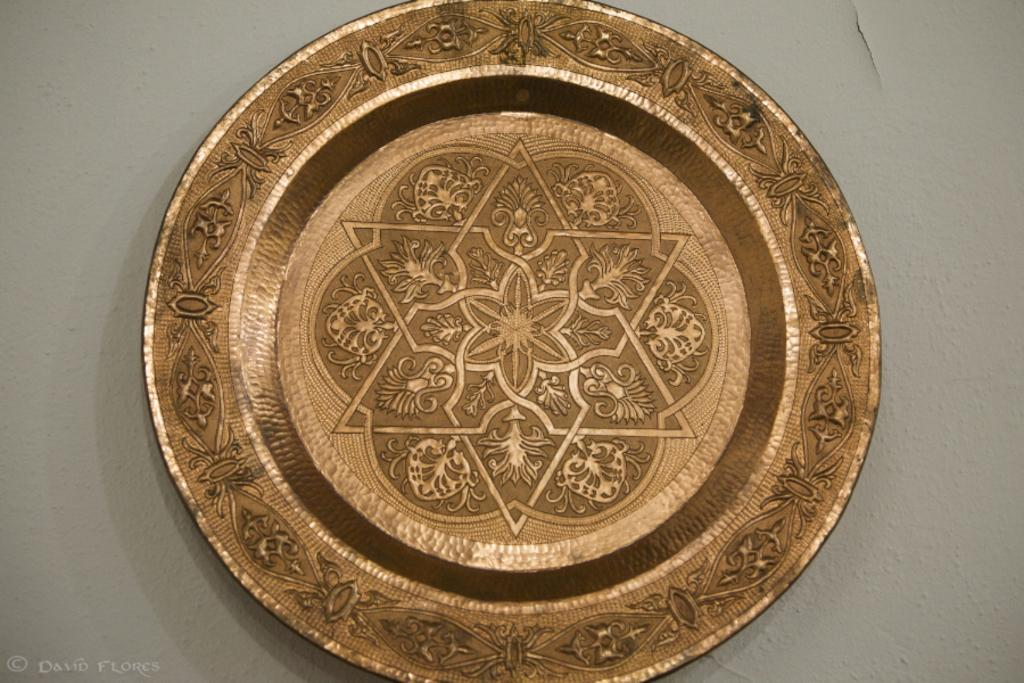What material is the plate made of in the image? The plate is made of bronze in the image. What can be seen on the surface of the plate? The plate has a design on it. What is the color of the surface on which the plate is placed? The plate is placed on a white surface. Where is the watermark located in the image? The watermark is on the bottom left side of the image. How does the plate increase in size during the conversation? The plate does not increase in size during the conversation, as it is a static image. 